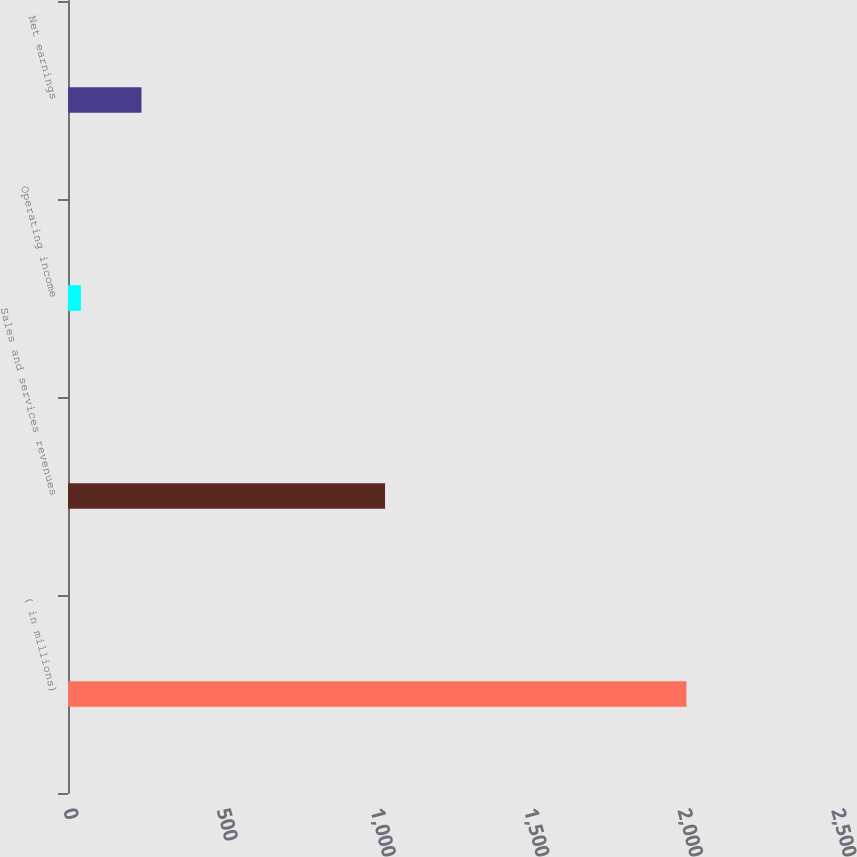<chart> <loc_0><loc_0><loc_500><loc_500><bar_chart><fcel>( in millions)<fcel>Sales and services revenues<fcel>Operating income<fcel>Net earnings<nl><fcel>2013<fcel>1032<fcel>42<fcel>239.1<nl></chart> 